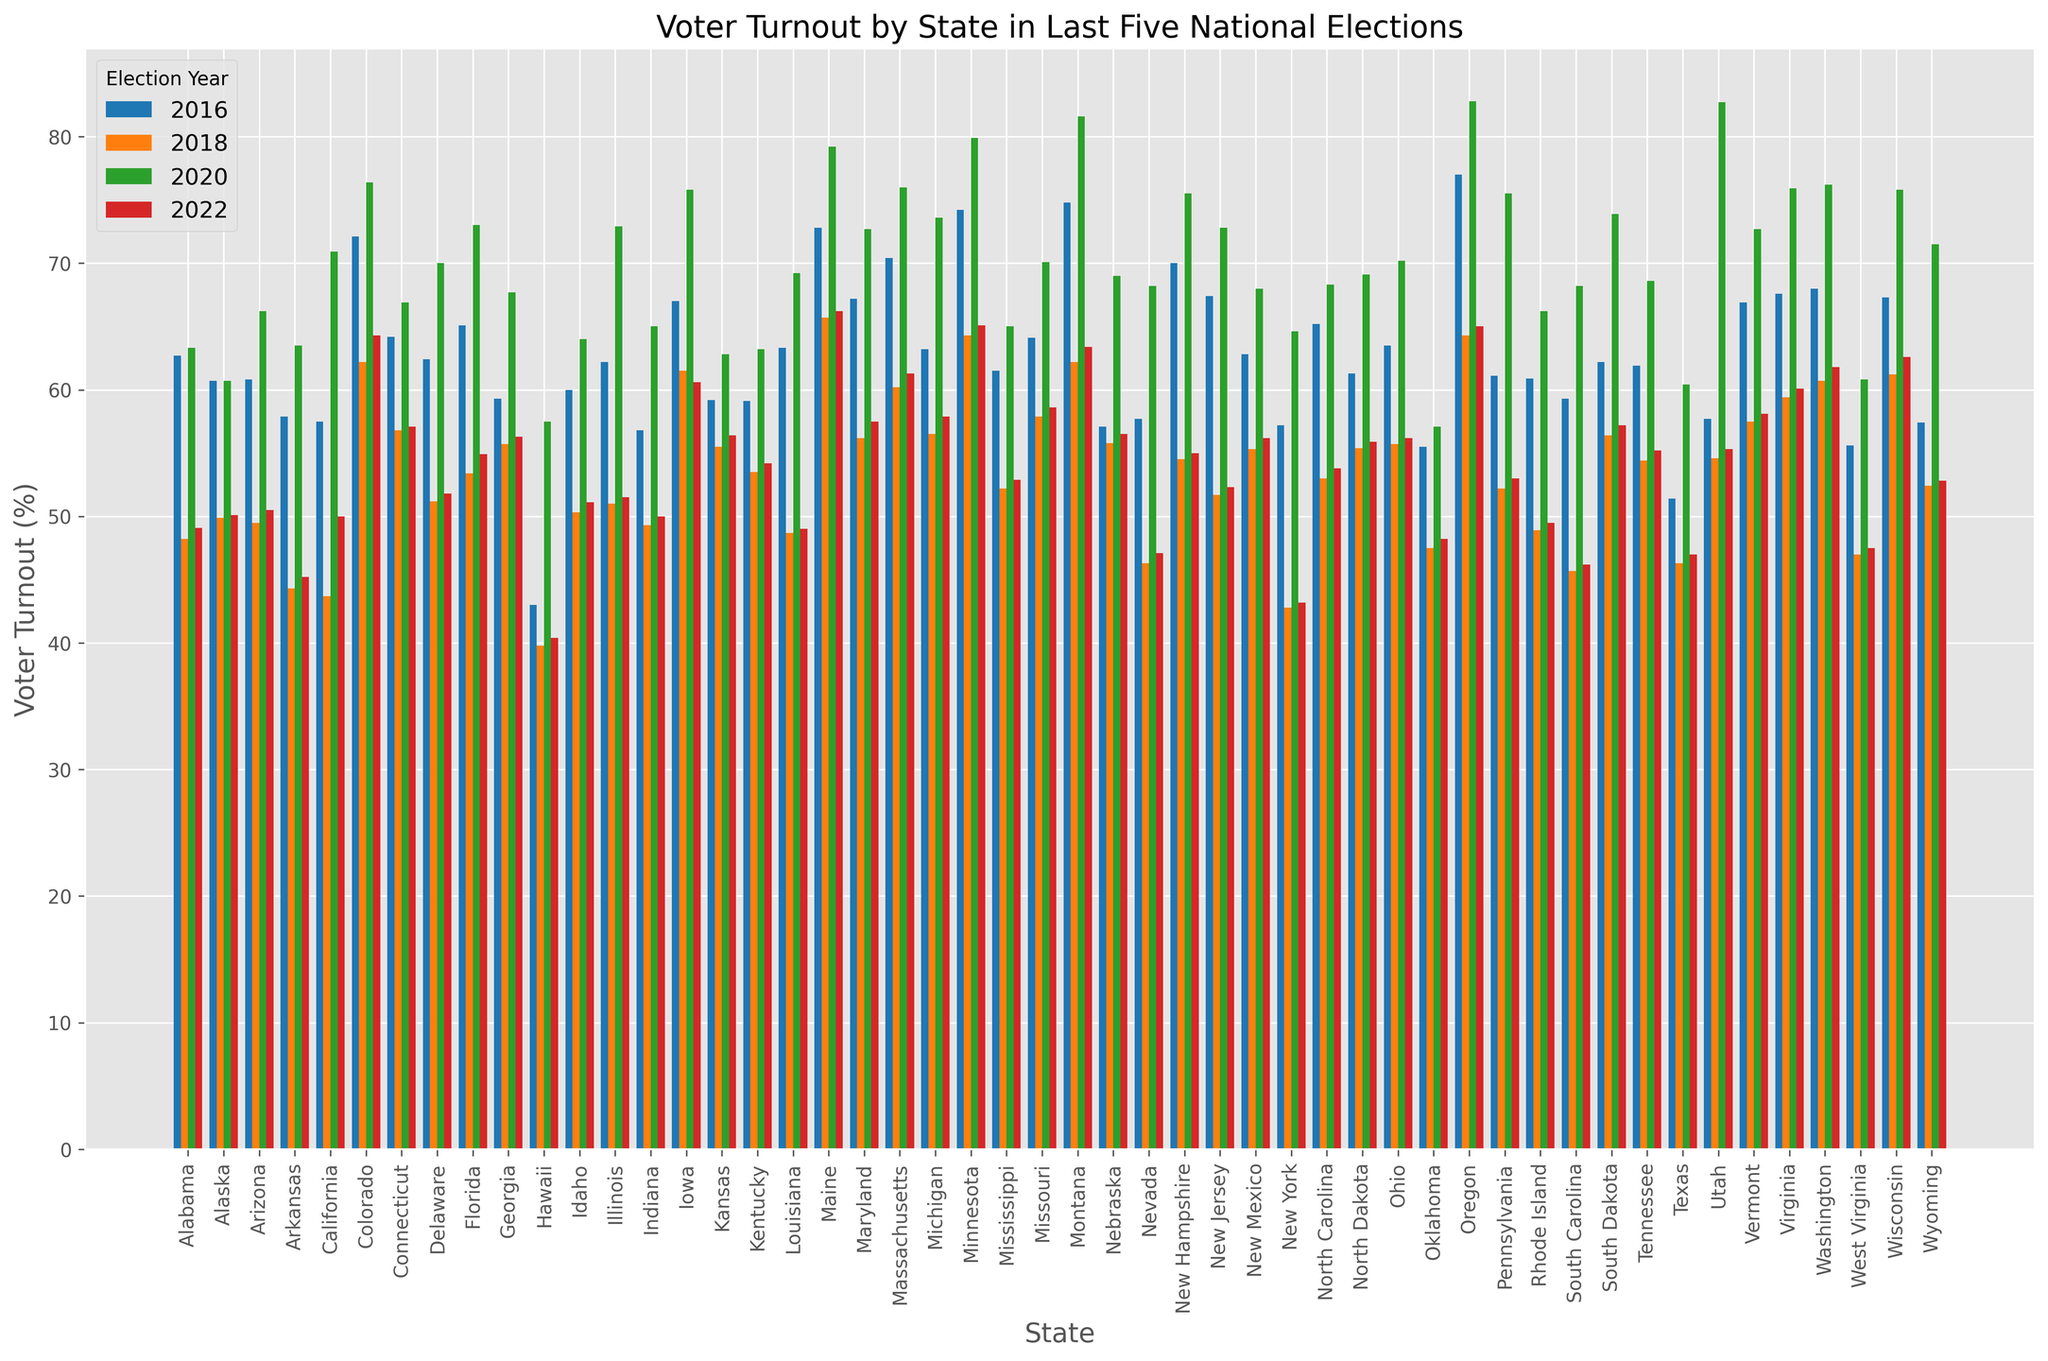Which state had the highest voter turnout in 2020? Look at the bar representing the year 2020, and identify the bar with the greatest height. This bar corresponds to Oregon with a voter turnout of 82.8%.
Answer: Oregon Which election year had the lowest voter turnout in Texas? Compare the height of the bars for Texas across all the years and find the shortest one. The lowest voter turnout was in 2018 with 46.3%.
Answer: 2018 How did the voter turnout in Alabama compare between 2016 and 2022? Look at the heights of the bars for Alabama in 2016 and 2022. The voter turnout was 62.7% in 2016 and slightly lower at 49.1% in 2022.
Answer: Decreased Which state had a higher voter turnout in 2022, Kansas or Kentucky? Compare the heights of the bars for Kansas and Kentucky in the year 2022. Kansas has a voter turnout of 56.4%, while Kentucky has 54.2%.
Answer: Kansas What is the difference in voter turnout between the highest and lowest states in 2020? Identify the states with the highest and lowest voter turnouts in 2020. Oregon has the highest at 82.8%, and Hawaii has the lowest at 57.5%. Calculate the difference: 82.8 - 57.5 = 25.3.
Answer: 25.3 What is the average voter turnout across all states for the year 2018? Sum up the voter turnouts for all states in 2018 and divide by the number of states (51). The total sum is 2733.3, so the average is 2733.3 / 51 ≈ 53.6.
Answer: 53.6 Which state showed the largest increase in voter turnout from 2016 to 2020? Calculate the difference in voter turnout for each state between 2016 and 2020. Utah's voter turnout increased the most, from 57.7% in 2016 to 82.7% in 2020, an increase of 25%.
Answer: Utah Which state had the smallest voter turnout in 2018? Compare the heights of all bars representing the year 2018 and find the shortest one. New York had the smallest voter turnout at 42.8%.
Answer: New York What is the median voter turnout for all states in 2022? Arrange the 2022 voter turnout values in ascending order and find the middle value. With 51 states, the median is the 26th value. The sorted list shows that the median is 54.2.
Answer: 54.2 